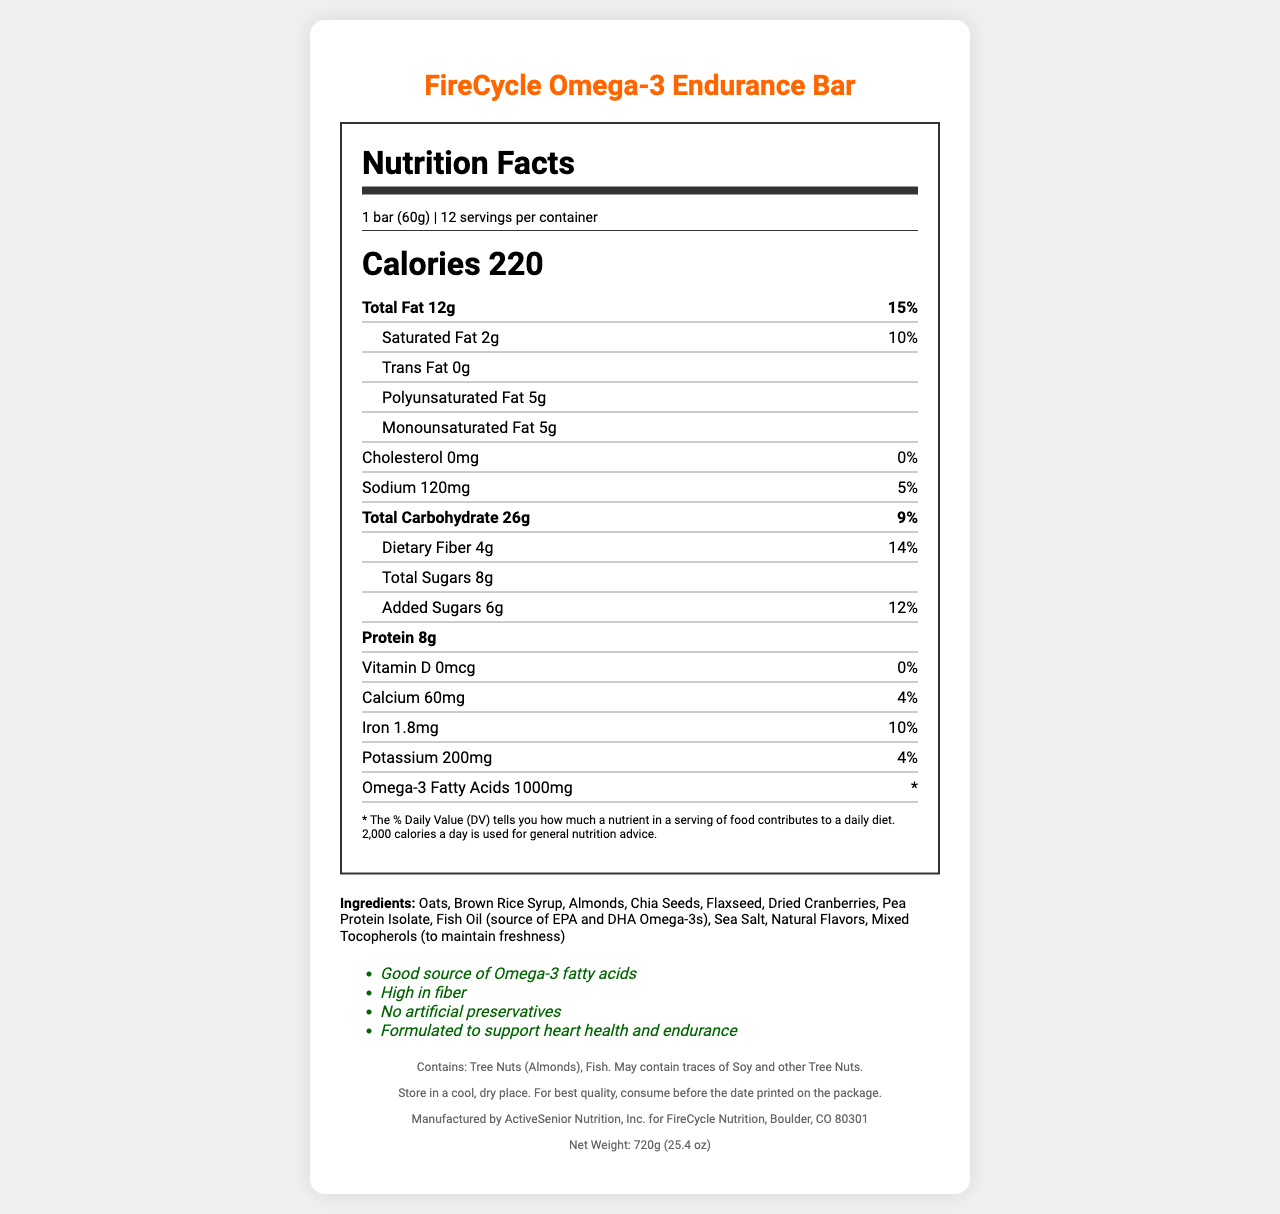what is the serving size of the FireCycle Omega-3 Endurance Bar? The serving size is clearly stated in the document as "1 bar (60g)".
Answer: 1 bar (60g) how many calories are in one serving of the energy bar? The document specifies that each serving contains 220 calories.
Answer: 220 what is the total fat content and its daily value percentage in one serving? The document lists the total fat content as 12g, which is 15% of the daily value.
Answer: 12g, 15% what are the polyunsaturated and monounsaturated fat contents per serving? The document specifies the amounts for both polyunsaturated and monounsaturated fats as 5g each.
Answer: Polyunsaturated Fat: 5g, Monounsaturated Fat: 5g how much dietary fiber is in one bar, and what percentage of the daily value does it represent? According to the document, each bar contains 4g of dietary fiber, which is 14% of the daily value.
Answer: 4g, 14% what allergens are present in this energy bar? The document explicitly states that the bar contains tree nuts (almonds) and fish and may contain traces of soy and other tree nuts.
Answer: Tree Nuts (Almonds), Fish what company manufactures the FireCycle Omega-3 Endurance Bar? The document mentions that the energy bar is manufactured by ActiveSenior Nutrition, Inc.
Answer: ActiveSenior Nutrition, Inc. how many grams of added sugars are in each serving? The document states that there are 6 grams of added sugars per serving.
Answer: 6g what is the omega-3 fatty acids content in one serving of the energy bar? A. 500mg B. 750mg C. 1000mg D. 1250mg The document lists the omega-3 fatty acids content as 1000mg per serving.
Answer: C which ingredient is NOT listed in the FireCycle Omega-3 Endurance Bar? A. Oats B. Honey C. Almonds D. Pea Protein Isolate Honey is not listed among the ingredients in the document.
Answer: B is this energy bar a good source of omega-3 fatty acids according to the document? The document claims that the bar is a good source of omega-3 fatty acids.
Answer: Yes can it be determined from the document if the energy bar is organic? The document does not provide any information regarding whether the energy bar is organic.
Answer: Cannot be determined summarize the key nutritional aspects and claims of the FireCycle Omega-3 Endurance Bar. The document summarizes the nutritional content, ingredients, and health claims associated with the FireCycle Omega-3 Endurance Bar, emphasizing its formulation for heart health and endurance.
Answer: The FireCycle Omega-3 Endurance Bar is designed for heart health and endurance. Each 60g bar contains 220 calories, 12g of fat (15% DV), 4g of dietary fiber (14% DV), and 8g of protein. It includes 1000mg of omega-3 fatty acids, primarily from fish oil. The bar contains no cholesterol, is high in fiber, and has no artificial preservatives. It is manufactured by ActiveSenior Nutrition, Inc. and contains tree nuts and fish. how much potassium does one serving provide, and what percentage of the daily value does that represent? The document specifies that one serving provides 200mg of potassium, which is 4% of the daily value.
Answer: 200mg, 4% what are the main claims made about the health benefits of the energy bar? The document lists these specific claims under the health claims section.
Answer: The main claims are that it is a good source of omega-3 fatty acids, high in fiber, contains no artificial preservatives, and is formulated to support heart health and endurance. what is the recommended storage condition for the FireCycle Omega-3 Endurance Bar? The document states that the bars should be stored in a cool, dry place for best quality.
Answer: Store in a cool, dry place. 